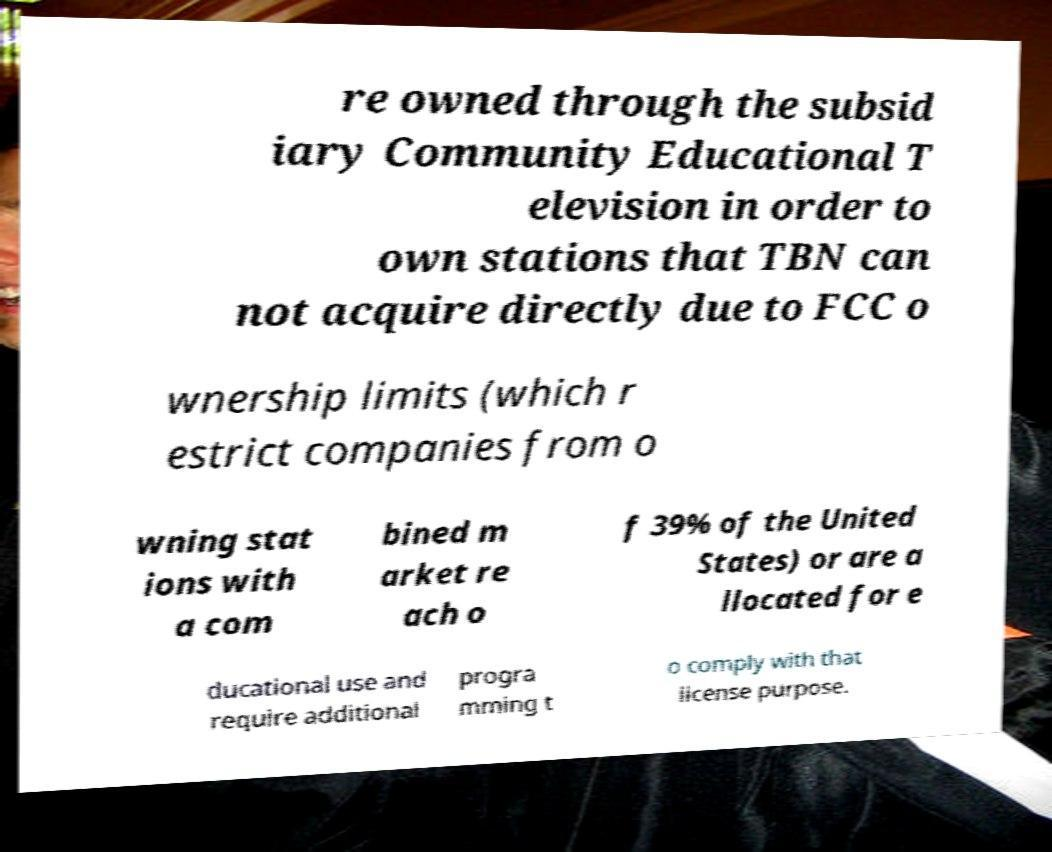Could you assist in decoding the text presented in this image and type it out clearly? re owned through the subsid iary Community Educational T elevision in order to own stations that TBN can not acquire directly due to FCC o wnership limits (which r estrict companies from o wning stat ions with a com bined m arket re ach o f 39% of the United States) or are a llocated for e ducational use and require additional progra mming t o comply with that license purpose. 